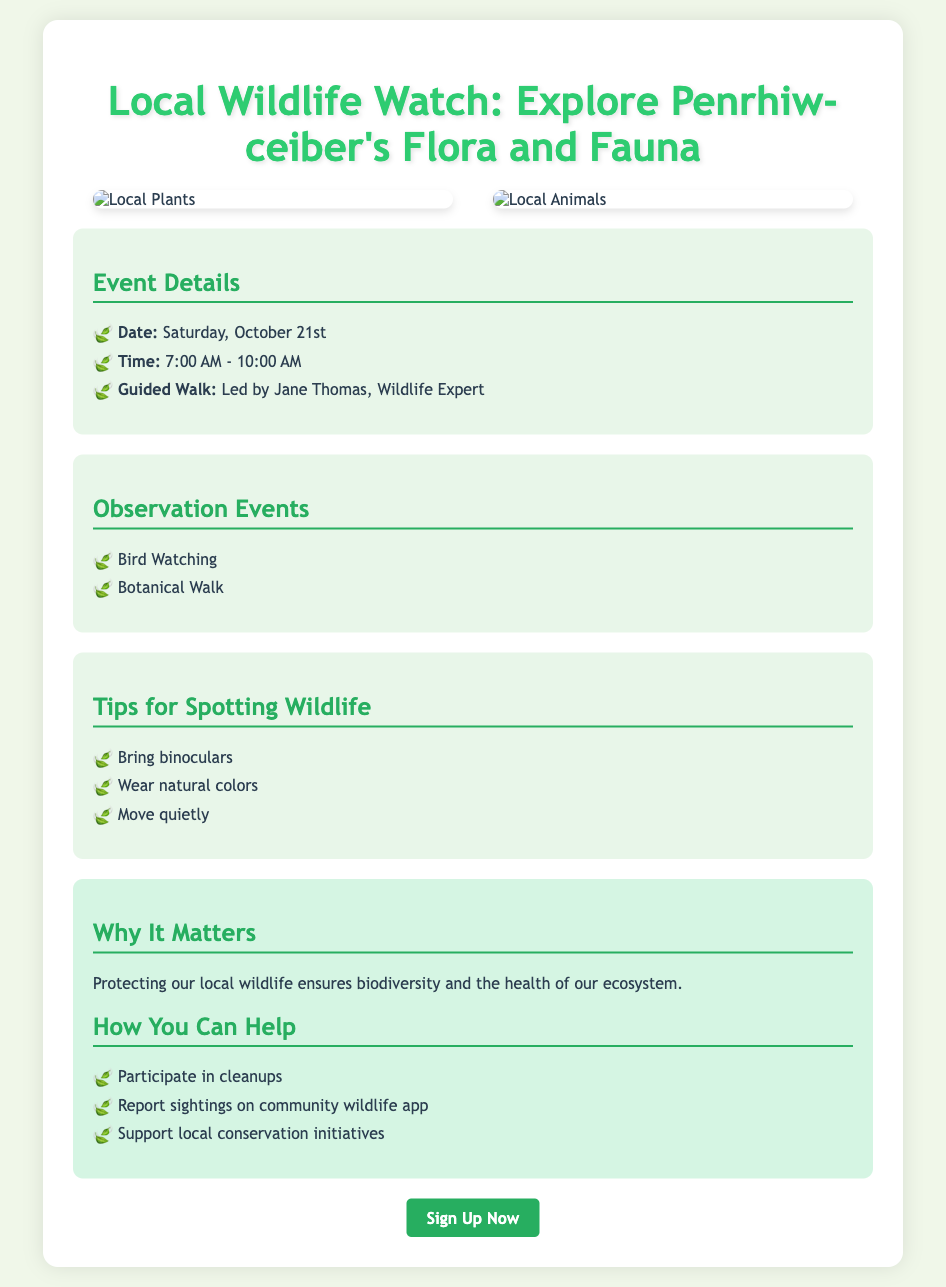What is the event date? The event date is explicitly mentioned as Saturday, October 21st in the document.
Answer: Saturday, October 21st What time does the event start? The starting time of the event is stated to be 7:00 AM in the details section.
Answer: 7:00 AM Who is leading the guided walk? The document provides the name of the wildlife expert leading the guided walk, which is Jane Thomas.
Answer: Jane Thomas What type of events will be included? The poster lists two types of observation events: Bird Watching and Botanical Walk.
Answer: Bird Watching, Botanical Walk What should participants bring to spot wildlife? The document suggests that participants should bring binoculars for wildlife spotting.
Answer: Binoculars Why is protecting local wildlife important? The document states that protecting local wildlife ensures biodiversity and ecosystem health.
Answer: Biodiversity and ecosystem health What colors are recommended to wear during the event? The poster advises participants to wear natural colors when spotting wildlife.
Answer: Natural colors What is one way residents can help with wildlife conservation? The document mentions several ways to help, one being to participate in cleanups.
Answer: Participate in cleanups 